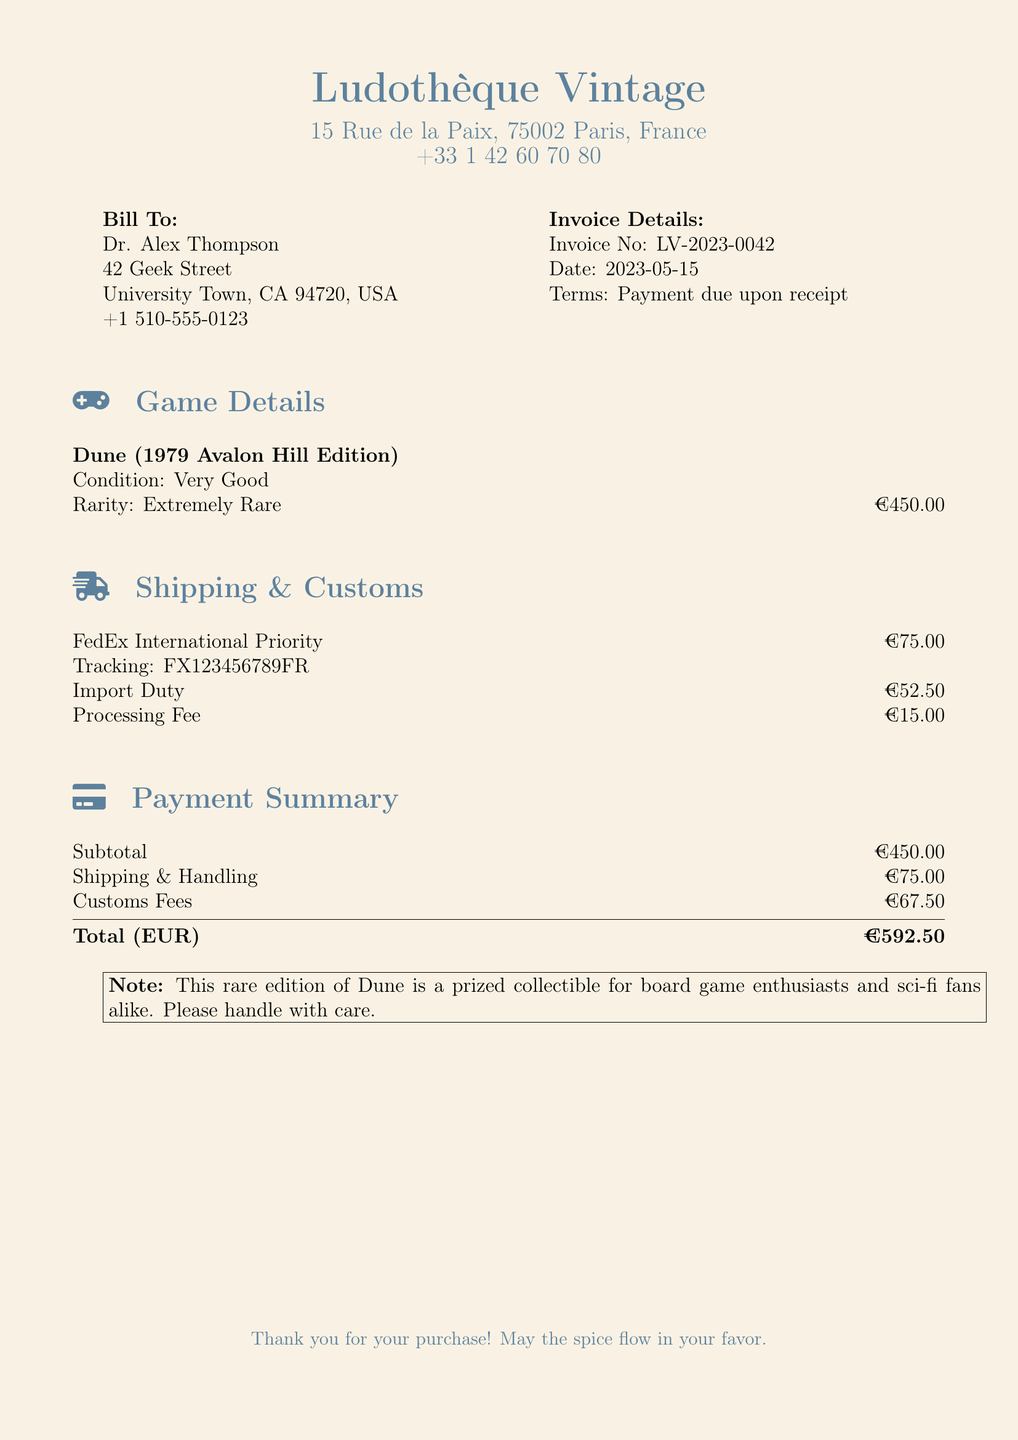What is the invoice number? The invoice number is clearly stated in the invoice details section of the document.
Answer: LV-2023-0042 What is the purchase date? The date of the invoice is mentioned in the invoice details section.
Answer: 2023-05-15 What is the condition of the game? The condition of the game is provided in the game details section.
Answer: Very Good What is the total customs fee? The customs fees are detailed in the shipping and customs section and need to be summed up for the total.
Answer: €67.50 What shipping method was used? The document specifies the shipping method in the shipping and customs section.
Answer: FedEx International Priority How much did shipping cost? The shipping cost is listed in the shipping and customs section of the document.
Answer: €75.00 What is the subtotal before customs fees? The subtotal is the cost of the game and is listed in the payment summary section.
Answer: €450.00 What is the total amount due? The total amount due is calculated in the payment summary section.
Answer: €592.50 What note is included regarding the game? The note provides specific handling instructions for the rare game in the document.
Answer: This rare edition of Dune is a prized collectible for board game enthusiasts and sci-fi fans alike. Please handle with care 